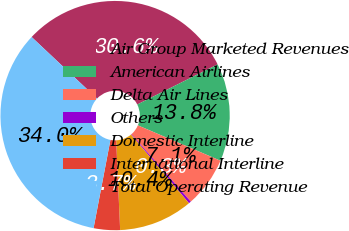Convert chart. <chart><loc_0><loc_0><loc_500><loc_500><pie_chart><fcel>Air Group Marketed Revenues<fcel>American Airlines<fcel>Delta Air Lines<fcel>Others<fcel>Domestic Interline<fcel>International Interline<fcel>Total Operating Revenue<nl><fcel>30.61%<fcel>13.81%<fcel>7.07%<fcel>0.34%<fcel>10.44%<fcel>3.71%<fcel>34.01%<nl></chart> 